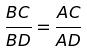<formula> <loc_0><loc_0><loc_500><loc_500>\frac { B C } { B D } = \frac { A C } { A D }</formula> 